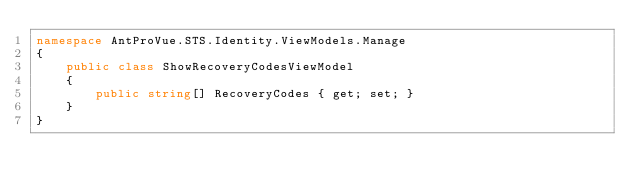Convert code to text. <code><loc_0><loc_0><loc_500><loc_500><_C#_>namespace AntProVue.STS.Identity.ViewModels.Manage
{
    public class ShowRecoveryCodesViewModel
    {
        public string[] RecoveryCodes { get; set; }
    }
}






</code> 